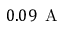<formula> <loc_0><loc_0><loc_500><loc_500>0 . 0 9 \, A</formula> 